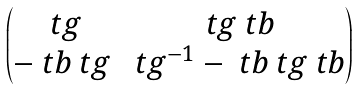<formula> <loc_0><loc_0><loc_500><loc_500>\begin{pmatrix} \ t g & \ t g \ t b \\ - \ t b \ t g & \ t g ^ { - 1 } - \ t b \ t g \ t b \end{pmatrix}</formula> 